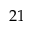Convert formula to latex. <formula><loc_0><loc_0><loc_500><loc_500>2 1</formula> 